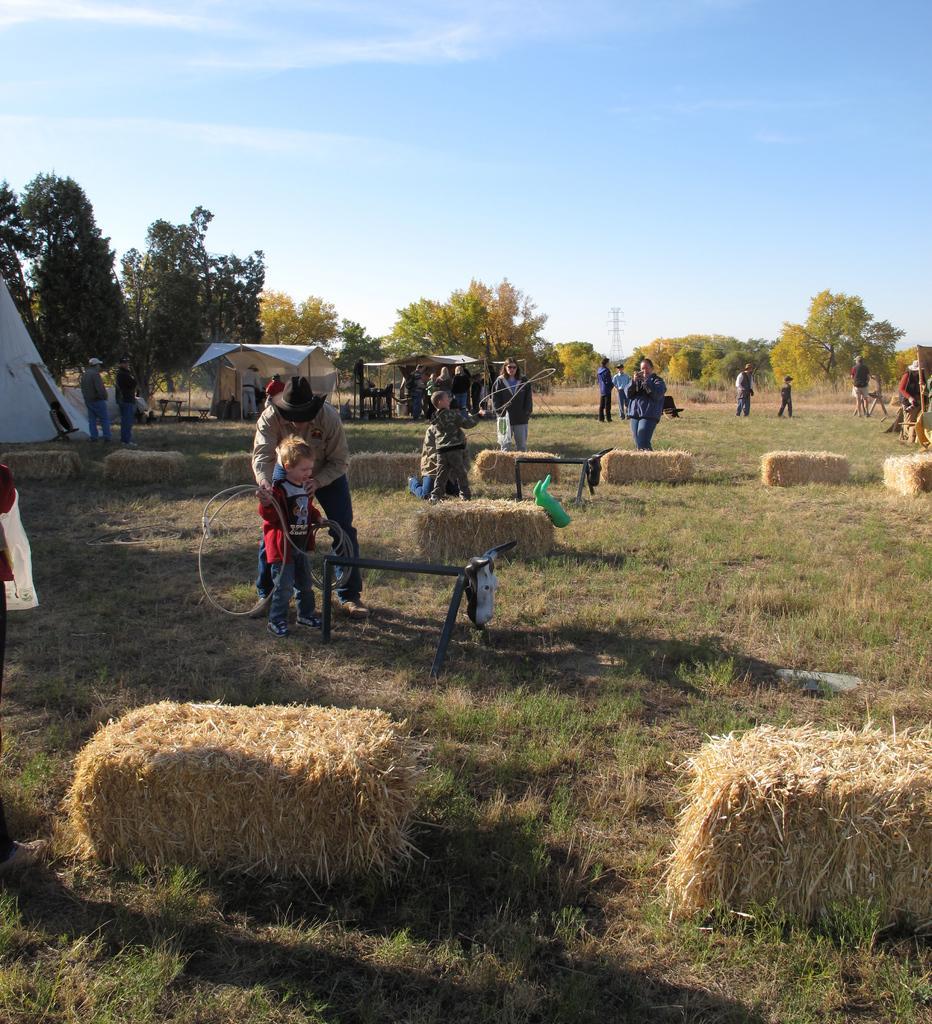How would you summarize this image in a sentence or two? In this image there are some persons standing in middle of this image and there are some trees in the background. There are some grass at bottom of this image. There is a tower at middle of this image and there is a sky at top of this image. 